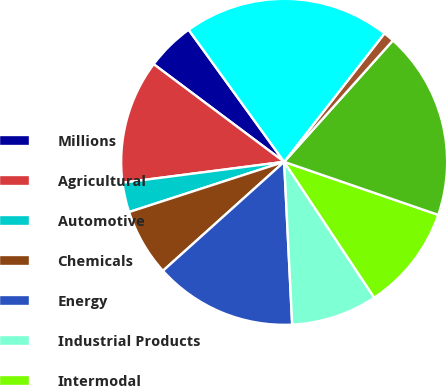Convert chart to OTSL. <chart><loc_0><loc_0><loc_500><loc_500><pie_chart><fcel>Millions<fcel>Agricultural<fcel>Automotive<fcel>Chemicals<fcel>Energy<fcel>Industrial Products<fcel>Intermodal<fcel>Total freight revenues<fcel>Other revenues<fcel>Total operating revenues<nl><fcel>4.81%<fcel>12.27%<fcel>2.94%<fcel>6.67%<fcel>14.13%<fcel>8.54%<fcel>10.4%<fcel>18.65%<fcel>1.07%<fcel>20.52%<nl></chart> 